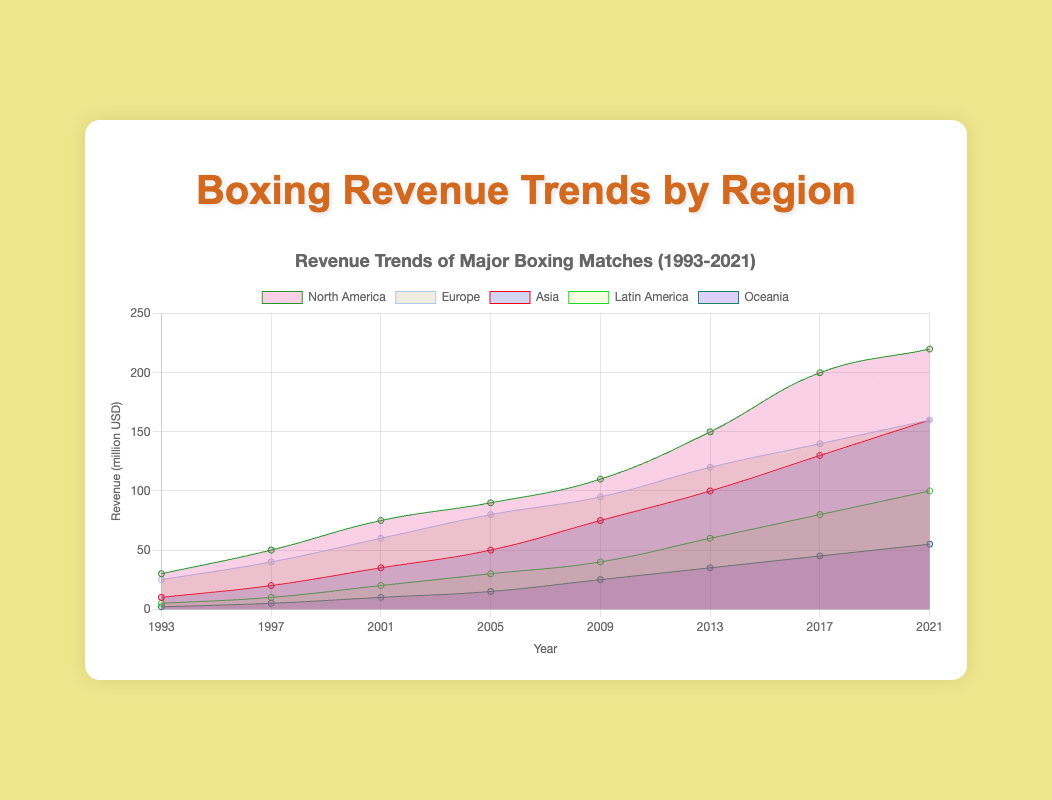What is the title of the chart? The title of the chart is prominently displayed at the top. It reads: "Boxing Revenue Trends by Region".
Answer: Boxing Revenue Trends by Region Which region had the highest revenue in 2021? By observing the height of the areas at the year 2021, we see that North America has the highest revenue.
Answer: North America Which region shows the most significant growth in revenue from 1993 to 2021? To determine the most significant growth, compare the starting and ending values of each region, calculating the difference. North America's revenue grew from 30 to 220, a growth of 190 million USD.
Answer: North America Compare the revenue of Europe and Asia in 2009. Which one is higher? From the chart, the height of the areas for Europe and Asia in 2009 can be compared directly. Europe had a higher revenue than Asia at that point.
Answer: Europe How much more revenue did Latin America generate in 2021 compared to 2005? Latin America's revenue in 2021 is 100 million USD, and in 2005 it was 30 million USD. The difference is calculated as 100 - 30 = 70 million USD.
Answer: 70 million USD Among all regions, which one showed the smallest revenue in 1993? The smallest area height in 1993 corresponds to Oceania's revenue.
Answer: Oceania What is the trend of boxing revenue in Asia from 1993 to 2021? By observing the area representing Asia, we see a steady increase in revenue over the years, indicating consistent growth.
Answer: Consistent growth If we sum up the revenue of all regions in 2013, what is the total? Adding the values from all regions for 2013: North America (150), Europe (120), Asia (100), Latin America (60), and Oceania (35) results in 465 million USD.
Answer: 465 million USD What is the average revenue of Oceania across all the given years? Summing the revenues of Oceania across all years: (2 + 5 + 10 + 15 + 25 + 35 + 45 + 55) = 192 and dividing by the number of years (8) gives an average of 192 / 8 = 24 million USD.
Answer: 24 million USD Which region shows the smallest revenue increase between 2009 and 2021? Calculate the difference between 2009 and 2021 values for each region and find the smallest: North America (220-110=110), Europe (160-95=65), Asia (160-75=85), Latin America (100-40=60), Oceania (55-25=30). Oceania has the smallest increase.
Answer: Oceania 